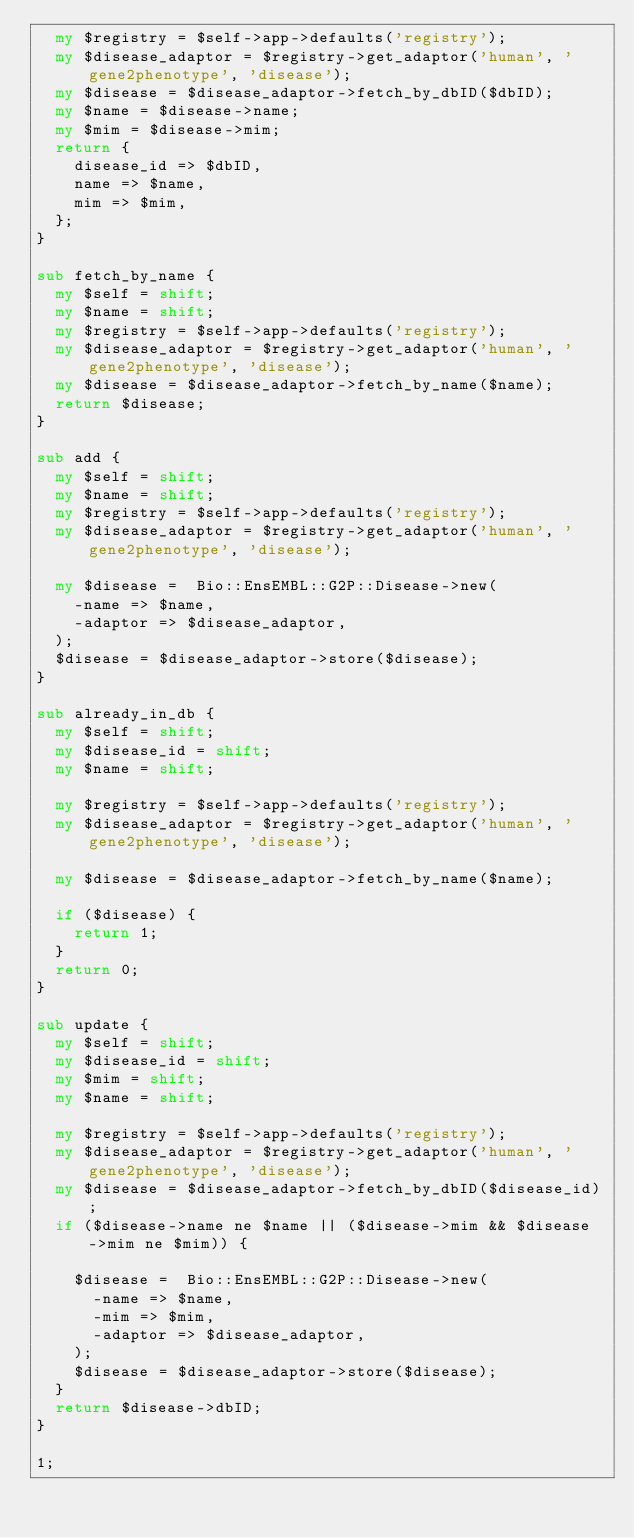Convert code to text. <code><loc_0><loc_0><loc_500><loc_500><_Perl_>  my $registry = $self->app->defaults('registry');
  my $disease_adaptor = $registry->get_adaptor('human', 'gene2phenotype', 'disease');
  my $disease = $disease_adaptor->fetch_by_dbID($dbID);
  my $name = $disease->name;
  my $mim = $disease->mim;
  return {
    disease_id => $dbID,
    name => $name,
    mim => $mim,
  };
}

sub fetch_by_name {
  my $self = shift;
  my $name = shift;
  my $registry = $self->app->defaults('registry');
  my $disease_adaptor = $registry->get_adaptor('human', 'gene2phenotype', 'disease');
  my $disease = $disease_adaptor->fetch_by_name($name);
  return $disease;
}

sub add {
  my $self = shift;
  my $name = shift;
  my $registry = $self->app->defaults('registry');
  my $disease_adaptor = $registry->get_adaptor('human', 'gene2phenotype', 'disease');

  my $disease =  Bio::EnsEMBL::G2P::Disease->new(
    -name => $name,
    -adaptor => $disease_adaptor,
  );
  $disease = $disease_adaptor->store($disease);
}

sub already_in_db {
  my $self = shift;
  my $disease_id = shift;
  my $name = shift;

  my $registry = $self->app->defaults('registry');
  my $disease_adaptor = $registry->get_adaptor('human', 'gene2phenotype', 'disease');

  my $disease = $disease_adaptor->fetch_by_name($name);

  if ($disease) {
    return 1;  
  }  
  return 0;
}

sub update {
  my $self = shift;
  my $disease_id = shift;
  my $mim = shift;
  my $name = shift;
  
  my $registry = $self->app->defaults('registry');
  my $disease_adaptor = $registry->get_adaptor('human', 'gene2phenotype', 'disease');
  my $disease = $disease_adaptor->fetch_by_dbID($disease_id);
  if ($disease->name ne $name || ($disease->mim && $disease->mim ne $mim)) {

    $disease =  Bio::EnsEMBL::G2P::Disease->new(
      -name => $name,
      -mim => $mim,
      -adaptor => $disease_adaptor,
    );
    $disease = $disease_adaptor->store($disease);
  }
  return $disease->dbID;
}

1;
</code> 